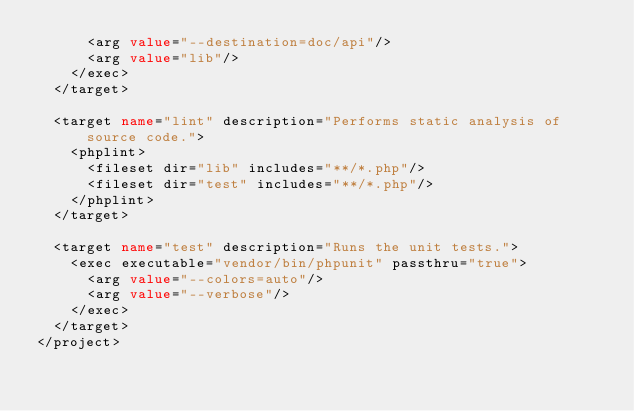Convert code to text. <code><loc_0><loc_0><loc_500><loc_500><_XML_>      <arg value="--destination=doc/api"/>
      <arg value="lib"/>
    </exec>
  </target>

  <target name="lint" description="Performs static analysis of source code.">
    <phplint>
      <fileset dir="lib" includes="**/*.php"/>
      <fileset dir="test" includes="**/*.php"/>
    </phplint>
  </target>

  <target name="test" description="Runs the unit tests.">
    <exec executable="vendor/bin/phpunit" passthru="true">
      <arg value="--colors=auto"/>
      <arg value="--verbose"/>
    </exec>
  </target>
</project>
</code> 